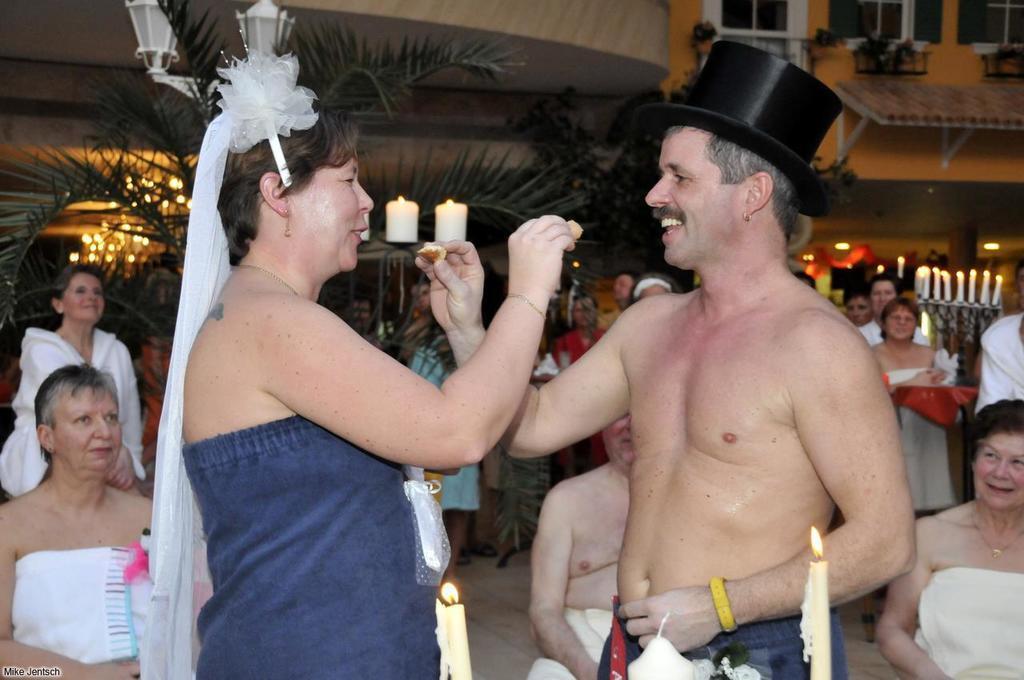Describe this image in one or two sentences. Here I can see a woman and a man holding some food items in their hands and smiling by looking at each other. In the background, I can see few people are sitting and few people are standing. At the bottom there are two candles. In the background there is a building, few trees and lights. On the right side there are few candles on a table. 